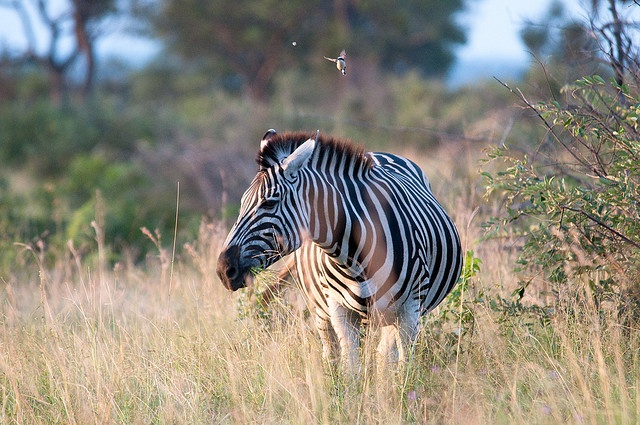Describe the objects in this image and their specific colors. I can see zebra in lightblue, black, gray, darkgray, and lightgray tones and bird in lightblue, darkgray, gray, ivory, and lightpink tones in this image. 